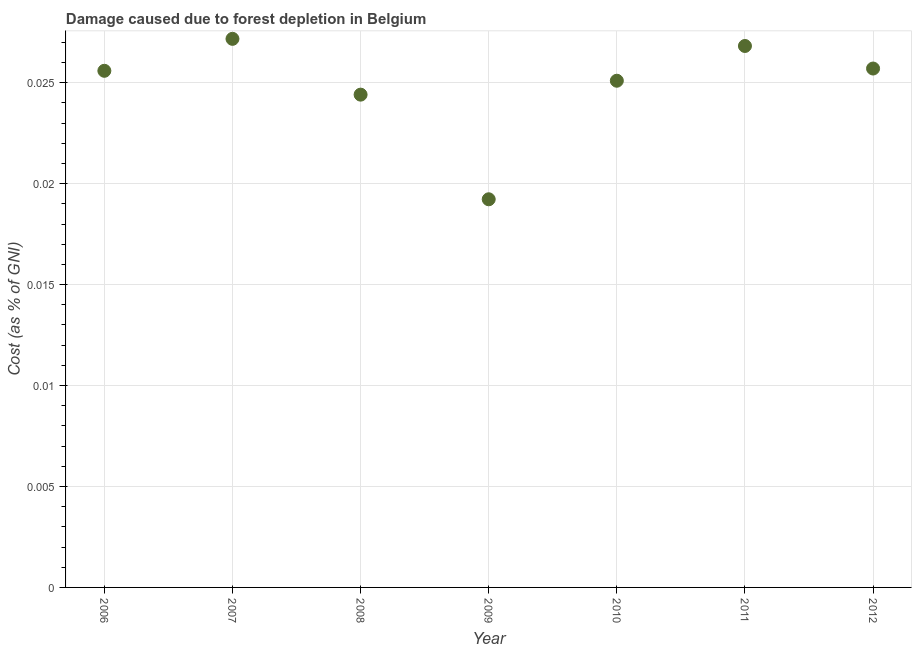What is the damage caused due to forest depletion in 2007?
Keep it short and to the point. 0.03. Across all years, what is the maximum damage caused due to forest depletion?
Provide a short and direct response. 0.03. Across all years, what is the minimum damage caused due to forest depletion?
Provide a short and direct response. 0.02. In which year was the damage caused due to forest depletion maximum?
Your answer should be very brief. 2007. In which year was the damage caused due to forest depletion minimum?
Offer a very short reply. 2009. What is the sum of the damage caused due to forest depletion?
Provide a short and direct response. 0.17. What is the difference between the damage caused due to forest depletion in 2006 and 2012?
Make the answer very short. -0. What is the average damage caused due to forest depletion per year?
Ensure brevity in your answer.  0.02. What is the median damage caused due to forest depletion?
Provide a short and direct response. 0.03. In how many years, is the damage caused due to forest depletion greater than 0.024 %?
Keep it short and to the point. 6. Do a majority of the years between 2012 and 2008 (inclusive) have damage caused due to forest depletion greater than 0.011 %?
Provide a succinct answer. Yes. What is the ratio of the damage caused due to forest depletion in 2010 to that in 2012?
Offer a terse response. 0.98. Is the damage caused due to forest depletion in 2008 less than that in 2012?
Provide a succinct answer. Yes. Is the difference between the damage caused due to forest depletion in 2011 and 2012 greater than the difference between any two years?
Give a very brief answer. No. What is the difference between the highest and the second highest damage caused due to forest depletion?
Ensure brevity in your answer.  0. What is the difference between the highest and the lowest damage caused due to forest depletion?
Provide a short and direct response. 0.01. In how many years, is the damage caused due to forest depletion greater than the average damage caused due to forest depletion taken over all years?
Ensure brevity in your answer.  5. Does the damage caused due to forest depletion monotonically increase over the years?
Make the answer very short. No. What is the difference between two consecutive major ticks on the Y-axis?
Your answer should be very brief. 0.01. Are the values on the major ticks of Y-axis written in scientific E-notation?
Give a very brief answer. No. Does the graph contain any zero values?
Make the answer very short. No. Does the graph contain grids?
Offer a terse response. Yes. What is the title of the graph?
Offer a terse response. Damage caused due to forest depletion in Belgium. What is the label or title of the Y-axis?
Your answer should be compact. Cost (as % of GNI). What is the Cost (as % of GNI) in 2006?
Provide a short and direct response. 0.03. What is the Cost (as % of GNI) in 2007?
Provide a succinct answer. 0.03. What is the Cost (as % of GNI) in 2008?
Offer a very short reply. 0.02. What is the Cost (as % of GNI) in 2009?
Your answer should be very brief. 0.02. What is the Cost (as % of GNI) in 2010?
Provide a short and direct response. 0.03. What is the Cost (as % of GNI) in 2011?
Give a very brief answer. 0.03. What is the Cost (as % of GNI) in 2012?
Make the answer very short. 0.03. What is the difference between the Cost (as % of GNI) in 2006 and 2007?
Provide a short and direct response. -0. What is the difference between the Cost (as % of GNI) in 2006 and 2008?
Provide a short and direct response. 0. What is the difference between the Cost (as % of GNI) in 2006 and 2009?
Make the answer very short. 0.01. What is the difference between the Cost (as % of GNI) in 2006 and 2010?
Provide a succinct answer. 0. What is the difference between the Cost (as % of GNI) in 2006 and 2011?
Your response must be concise. -0. What is the difference between the Cost (as % of GNI) in 2006 and 2012?
Offer a very short reply. -0. What is the difference between the Cost (as % of GNI) in 2007 and 2008?
Your answer should be compact. 0. What is the difference between the Cost (as % of GNI) in 2007 and 2009?
Make the answer very short. 0.01. What is the difference between the Cost (as % of GNI) in 2007 and 2010?
Your response must be concise. 0. What is the difference between the Cost (as % of GNI) in 2007 and 2011?
Offer a terse response. 0. What is the difference between the Cost (as % of GNI) in 2007 and 2012?
Give a very brief answer. 0. What is the difference between the Cost (as % of GNI) in 2008 and 2009?
Your answer should be compact. 0.01. What is the difference between the Cost (as % of GNI) in 2008 and 2010?
Provide a succinct answer. -0. What is the difference between the Cost (as % of GNI) in 2008 and 2011?
Ensure brevity in your answer.  -0. What is the difference between the Cost (as % of GNI) in 2008 and 2012?
Your answer should be compact. -0. What is the difference between the Cost (as % of GNI) in 2009 and 2010?
Ensure brevity in your answer.  -0.01. What is the difference between the Cost (as % of GNI) in 2009 and 2011?
Provide a short and direct response. -0.01. What is the difference between the Cost (as % of GNI) in 2009 and 2012?
Your response must be concise. -0.01. What is the difference between the Cost (as % of GNI) in 2010 and 2011?
Ensure brevity in your answer.  -0. What is the difference between the Cost (as % of GNI) in 2010 and 2012?
Provide a short and direct response. -0. What is the difference between the Cost (as % of GNI) in 2011 and 2012?
Make the answer very short. 0. What is the ratio of the Cost (as % of GNI) in 2006 to that in 2007?
Your answer should be compact. 0.94. What is the ratio of the Cost (as % of GNI) in 2006 to that in 2008?
Offer a terse response. 1.05. What is the ratio of the Cost (as % of GNI) in 2006 to that in 2009?
Give a very brief answer. 1.33. What is the ratio of the Cost (as % of GNI) in 2006 to that in 2011?
Provide a short and direct response. 0.95. What is the ratio of the Cost (as % of GNI) in 2007 to that in 2008?
Ensure brevity in your answer.  1.11. What is the ratio of the Cost (as % of GNI) in 2007 to that in 2009?
Give a very brief answer. 1.41. What is the ratio of the Cost (as % of GNI) in 2007 to that in 2010?
Your answer should be compact. 1.08. What is the ratio of the Cost (as % of GNI) in 2007 to that in 2012?
Ensure brevity in your answer.  1.06. What is the ratio of the Cost (as % of GNI) in 2008 to that in 2009?
Your answer should be compact. 1.27. What is the ratio of the Cost (as % of GNI) in 2008 to that in 2010?
Give a very brief answer. 0.97. What is the ratio of the Cost (as % of GNI) in 2008 to that in 2011?
Keep it short and to the point. 0.91. What is the ratio of the Cost (as % of GNI) in 2008 to that in 2012?
Provide a short and direct response. 0.95. What is the ratio of the Cost (as % of GNI) in 2009 to that in 2010?
Your answer should be compact. 0.77. What is the ratio of the Cost (as % of GNI) in 2009 to that in 2011?
Give a very brief answer. 0.72. What is the ratio of the Cost (as % of GNI) in 2009 to that in 2012?
Your answer should be very brief. 0.75. What is the ratio of the Cost (as % of GNI) in 2010 to that in 2011?
Your response must be concise. 0.94. What is the ratio of the Cost (as % of GNI) in 2011 to that in 2012?
Your response must be concise. 1.04. 